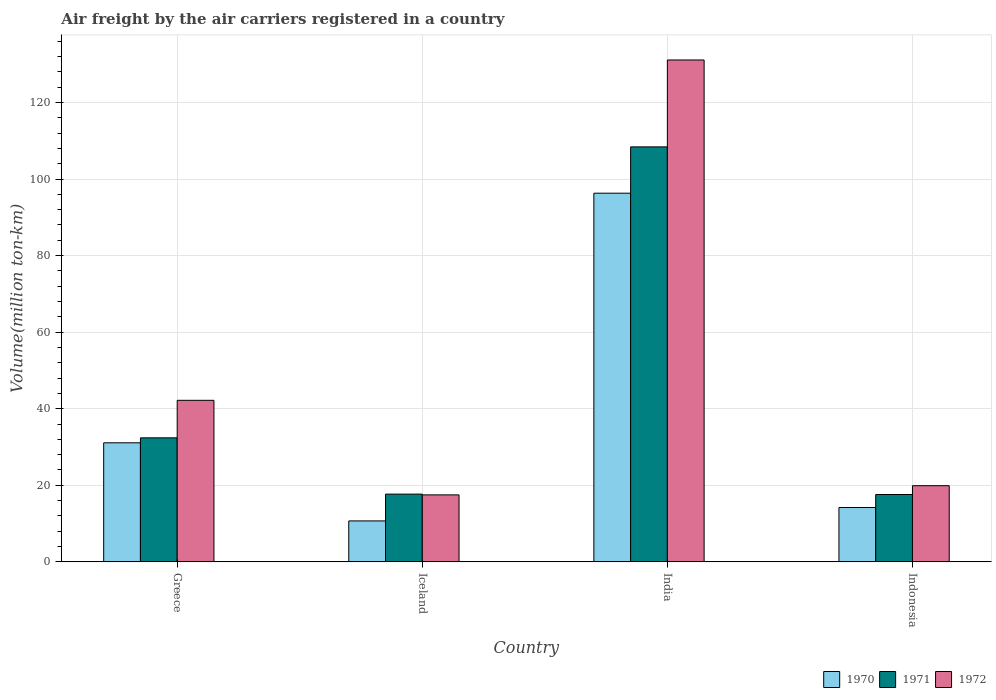How many different coloured bars are there?
Your response must be concise. 3. What is the label of the 3rd group of bars from the left?
Keep it short and to the point. India. In how many cases, is the number of bars for a given country not equal to the number of legend labels?
Offer a very short reply. 0. Across all countries, what is the maximum volume of the air carriers in 1972?
Provide a succinct answer. 131.1. Across all countries, what is the minimum volume of the air carriers in 1971?
Give a very brief answer. 17.6. In which country was the volume of the air carriers in 1971 minimum?
Give a very brief answer. Indonesia. What is the total volume of the air carriers in 1970 in the graph?
Give a very brief answer. 152.3. What is the difference between the volume of the air carriers in 1971 in Greece and that in Iceland?
Offer a terse response. 14.7. What is the difference between the volume of the air carriers in 1971 in Greece and the volume of the air carriers in 1972 in India?
Make the answer very short. -98.7. What is the average volume of the air carriers in 1971 per country?
Your answer should be very brief. 44.03. What is the difference between the volume of the air carriers of/in 1972 and volume of the air carriers of/in 1970 in India?
Ensure brevity in your answer.  34.8. In how many countries, is the volume of the air carriers in 1971 greater than 28 million ton-km?
Offer a very short reply. 2. What is the ratio of the volume of the air carriers in 1971 in India to that in Indonesia?
Offer a very short reply. 6.16. What is the difference between the highest and the second highest volume of the air carriers in 1971?
Your response must be concise. 14.7. What is the difference between the highest and the lowest volume of the air carriers in 1970?
Provide a succinct answer. 85.6. In how many countries, is the volume of the air carriers in 1971 greater than the average volume of the air carriers in 1971 taken over all countries?
Your answer should be compact. 1. What does the 1st bar from the left in India represents?
Ensure brevity in your answer.  1970. What does the 3rd bar from the right in India represents?
Your response must be concise. 1970. How many bars are there?
Provide a succinct answer. 12. Are the values on the major ticks of Y-axis written in scientific E-notation?
Provide a succinct answer. No. Does the graph contain grids?
Your response must be concise. Yes. How many legend labels are there?
Make the answer very short. 3. How are the legend labels stacked?
Your answer should be very brief. Horizontal. What is the title of the graph?
Provide a succinct answer. Air freight by the air carriers registered in a country. Does "1991" appear as one of the legend labels in the graph?
Your answer should be very brief. No. What is the label or title of the Y-axis?
Offer a terse response. Volume(million ton-km). What is the Volume(million ton-km) of 1970 in Greece?
Ensure brevity in your answer.  31.1. What is the Volume(million ton-km) in 1971 in Greece?
Ensure brevity in your answer.  32.4. What is the Volume(million ton-km) in 1972 in Greece?
Keep it short and to the point. 42.2. What is the Volume(million ton-km) of 1970 in Iceland?
Ensure brevity in your answer.  10.7. What is the Volume(million ton-km) of 1971 in Iceland?
Make the answer very short. 17.7. What is the Volume(million ton-km) in 1972 in Iceland?
Ensure brevity in your answer.  17.5. What is the Volume(million ton-km) in 1970 in India?
Provide a succinct answer. 96.3. What is the Volume(million ton-km) in 1971 in India?
Offer a terse response. 108.4. What is the Volume(million ton-km) in 1972 in India?
Offer a terse response. 131.1. What is the Volume(million ton-km) of 1970 in Indonesia?
Your answer should be compact. 14.2. What is the Volume(million ton-km) of 1971 in Indonesia?
Your answer should be very brief. 17.6. What is the Volume(million ton-km) of 1972 in Indonesia?
Provide a short and direct response. 19.9. Across all countries, what is the maximum Volume(million ton-km) in 1970?
Keep it short and to the point. 96.3. Across all countries, what is the maximum Volume(million ton-km) in 1971?
Make the answer very short. 108.4. Across all countries, what is the maximum Volume(million ton-km) in 1972?
Keep it short and to the point. 131.1. Across all countries, what is the minimum Volume(million ton-km) in 1970?
Your response must be concise. 10.7. Across all countries, what is the minimum Volume(million ton-km) of 1971?
Keep it short and to the point. 17.6. What is the total Volume(million ton-km) of 1970 in the graph?
Provide a succinct answer. 152.3. What is the total Volume(million ton-km) in 1971 in the graph?
Keep it short and to the point. 176.1. What is the total Volume(million ton-km) in 1972 in the graph?
Your response must be concise. 210.7. What is the difference between the Volume(million ton-km) in 1970 in Greece and that in Iceland?
Your response must be concise. 20.4. What is the difference between the Volume(million ton-km) of 1972 in Greece and that in Iceland?
Offer a terse response. 24.7. What is the difference between the Volume(million ton-km) of 1970 in Greece and that in India?
Your answer should be compact. -65.2. What is the difference between the Volume(million ton-km) of 1971 in Greece and that in India?
Provide a succinct answer. -76. What is the difference between the Volume(million ton-km) of 1972 in Greece and that in India?
Make the answer very short. -88.9. What is the difference between the Volume(million ton-km) of 1972 in Greece and that in Indonesia?
Provide a succinct answer. 22.3. What is the difference between the Volume(million ton-km) in 1970 in Iceland and that in India?
Your answer should be very brief. -85.6. What is the difference between the Volume(million ton-km) in 1971 in Iceland and that in India?
Provide a short and direct response. -90.7. What is the difference between the Volume(million ton-km) in 1972 in Iceland and that in India?
Offer a very short reply. -113.6. What is the difference between the Volume(million ton-km) of 1971 in Iceland and that in Indonesia?
Your response must be concise. 0.1. What is the difference between the Volume(million ton-km) of 1972 in Iceland and that in Indonesia?
Ensure brevity in your answer.  -2.4. What is the difference between the Volume(million ton-km) of 1970 in India and that in Indonesia?
Give a very brief answer. 82.1. What is the difference between the Volume(million ton-km) of 1971 in India and that in Indonesia?
Your answer should be very brief. 90.8. What is the difference between the Volume(million ton-km) in 1972 in India and that in Indonesia?
Offer a very short reply. 111.2. What is the difference between the Volume(million ton-km) in 1970 in Greece and the Volume(million ton-km) in 1972 in Iceland?
Your answer should be very brief. 13.6. What is the difference between the Volume(million ton-km) of 1971 in Greece and the Volume(million ton-km) of 1972 in Iceland?
Ensure brevity in your answer.  14.9. What is the difference between the Volume(million ton-km) of 1970 in Greece and the Volume(million ton-km) of 1971 in India?
Provide a short and direct response. -77.3. What is the difference between the Volume(million ton-km) in 1970 in Greece and the Volume(million ton-km) in 1972 in India?
Give a very brief answer. -100. What is the difference between the Volume(million ton-km) of 1971 in Greece and the Volume(million ton-km) of 1972 in India?
Make the answer very short. -98.7. What is the difference between the Volume(million ton-km) of 1970 in Greece and the Volume(million ton-km) of 1972 in Indonesia?
Ensure brevity in your answer.  11.2. What is the difference between the Volume(million ton-km) in 1971 in Greece and the Volume(million ton-km) in 1972 in Indonesia?
Offer a terse response. 12.5. What is the difference between the Volume(million ton-km) of 1970 in Iceland and the Volume(million ton-km) of 1971 in India?
Keep it short and to the point. -97.7. What is the difference between the Volume(million ton-km) in 1970 in Iceland and the Volume(million ton-km) in 1972 in India?
Your answer should be very brief. -120.4. What is the difference between the Volume(million ton-km) of 1971 in Iceland and the Volume(million ton-km) of 1972 in India?
Give a very brief answer. -113.4. What is the difference between the Volume(million ton-km) in 1970 in Iceland and the Volume(million ton-km) in 1972 in Indonesia?
Your response must be concise. -9.2. What is the difference between the Volume(million ton-km) in 1970 in India and the Volume(million ton-km) in 1971 in Indonesia?
Provide a short and direct response. 78.7. What is the difference between the Volume(million ton-km) in 1970 in India and the Volume(million ton-km) in 1972 in Indonesia?
Keep it short and to the point. 76.4. What is the difference between the Volume(million ton-km) of 1971 in India and the Volume(million ton-km) of 1972 in Indonesia?
Keep it short and to the point. 88.5. What is the average Volume(million ton-km) in 1970 per country?
Your answer should be compact. 38.08. What is the average Volume(million ton-km) of 1971 per country?
Give a very brief answer. 44.02. What is the average Volume(million ton-km) of 1972 per country?
Your answer should be very brief. 52.67. What is the difference between the Volume(million ton-km) in 1970 and Volume(million ton-km) in 1971 in Greece?
Your response must be concise. -1.3. What is the difference between the Volume(million ton-km) in 1970 and Volume(million ton-km) in 1972 in Iceland?
Your answer should be compact. -6.8. What is the difference between the Volume(million ton-km) in 1970 and Volume(million ton-km) in 1972 in India?
Keep it short and to the point. -34.8. What is the difference between the Volume(million ton-km) of 1971 and Volume(million ton-km) of 1972 in India?
Your answer should be compact. -22.7. What is the difference between the Volume(million ton-km) of 1970 and Volume(million ton-km) of 1971 in Indonesia?
Keep it short and to the point. -3.4. What is the ratio of the Volume(million ton-km) of 1970 in Greece to that in Iceland?
Make the answer very short. 2.91. What is the ratio of the Volume(million ton-km) in 1971 in Greece to that in Iceland?
Keep it short and to the point. 1.83. What is the ratio of the Volume(million ton-km) of 1972 in Greece to that in Iceland?
Offer a terse response. 2.41. What is the ratio of the Volume(million ton-km) of 1970 in Greece to that in India?
Your answer should be compact. 0.32. What is the ratio of the Volume(million ton-km) in 1971 in Greece to that in India?
Offer a terse response. 0.3. What is the ratio of the Volume(million ton-km) in 1972 in Greece to that in India?
Your answer should be very brief. 0.32. What is the ratio of the Volume(million ton-km) of 1970 in Greece to that in Indonesia?
Provide a short and direct response. 2.19. What is the ratio of the Volume(million ton-km) in 1971 in Greece to that in Indonesia?
Provide a succinct answer. 1.84. What is the ratio of the Volume(million ton-km) of 1972 in Greece to that in Indonesia?
Your answer should be very brief. 2.12. What is the ratio of the Volume(million ton-km) of 1971 in Iceland to that in India?
Keep it short and to the point. 0.16. What is the ratio of the Volume(million ton-km) in 1972 in Iceland to that in India?
Ensure brevity in your answer.  0.13. What is the ratio of the Volume(million ton-km) in 1970 in Iceland to that in Indonesia?
Your answer should be compact. 0.75. What is the ratio of the Volume(million ton-km) of 1971 in Iceland to that in Indonesia?
Your response must be concise. 1.01. What is the ratio of the Volume(million ton-km) of 1972 in Iceland to that in Indonesia?
Ensure brevity in your answer.  0.88. What is the ratio of the Volume(million ton-km) of 1970 in India to that in Indonesia?
Give a very brief answer. 6.78. What is the ratio of the Volume(million ton-km) of 1971 in India to that in Indonesia?
Offer a very short reply. 6.16. What is the ratio of the Volume(million ton-km) in 1972 in India to that in Indonesia?
Your response must be concise. 6.59. What is the difference between the highest and the second highest Volume(million ton-km) in 1970?
Give a very brief answer. 65.2. What is the difference between the highest and the second highest Volume(million ton-km) in 1971?
Give a very brief answer. 76. What is the difference between the highest and the second highest Volume(million ton-km) in 1972?
Your answer should be compact. 88.9. What is the difference between the highest and the lowest Volume(million ton-km) of 1970?
Give a very brief answer. 85.6. What is the difference between the highest and the lowest Volume(million ton-km) in 1971?
Offer a terse response. 90.8. What is the difference between the highest and the lowest Volume(million ton-km) of 1972?
Keep it short and to the point. 113.6. 